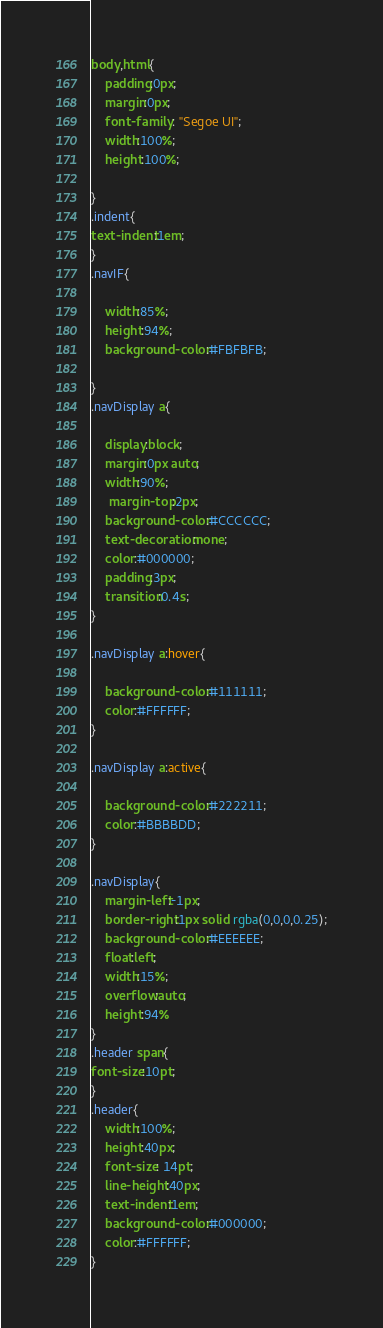Convert code to text. <code><loc_0><loc_0><loc_500><loc_500><_CSS_>body,html{
    padding:0px;
    margin:0px;
    font-family : "Segoe UI";
    width:100%;
    height:100%;
	
}
.indent{
text-indent:1em;
}
.navIF{
    
	width:85%;
    height:94%;
	background-color:#FBFBFB;
	
}
.navDisplay a{
   
    display:block;
    margin:0px auto;
    width:90%;
     margin-top:2px;
    background-color:#CCCCCC;
    text-decoration:none;
    color:#000000;
    padding:3px;
    transition:0.4s;
}

.navDisplay a:hover{
   
    background-color:#111111;
    color:#FFFFFF;
}

.navDisplay a:active{
   
    background-color:#222211;
    color:#BBBBDD;
}

.navDisplay{
	margin-left:-1px;
	border-right:1px solid rgba(0,0,0,0.25);
    background-color:#EEEEEE;
    float:left;
    width:15%;
    overflow:auto;
    height:94%
}
.header span{
font-size:10pt;
}
.header{
    width:100%;
    height:40px;
    font-size: 14pt;
    line-height:40px;
    text-indent:1em;
    background-color:#000000;
    color:#FFFFFF;
}</code> 